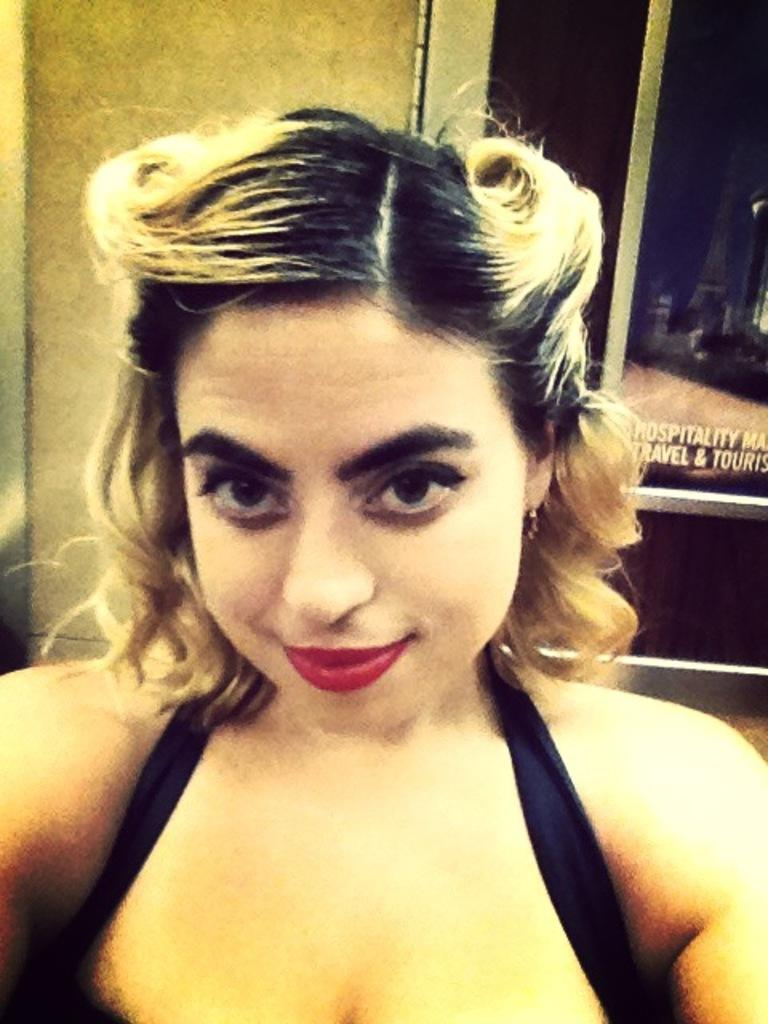Who is present in the image? There is a woman in the image. What can be seen in the background of the image? There is a glass door and a wall visible in the background of the image. Can you describe the glass door in the image? The glass door has text visible on it. What type of note is the woman holding in the image? There is no note visible in the image; the woman is not holding anything. 